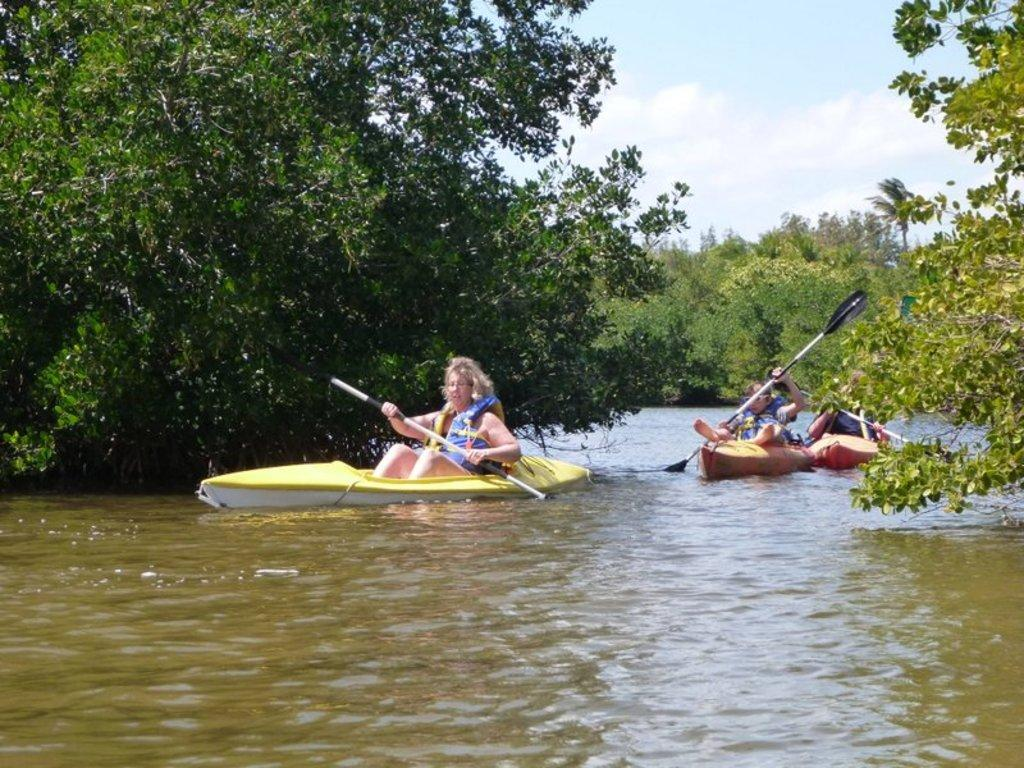How many people are in the image? There are three people in the image. What are the people doing in the image? The people are sitting in boats and holding rows. Where are the boats located? The boats are in a large water body. What can be seen in the background of the image? There is a group of trees visible in the image, and the sky is cloudy. Are the people wearing veils in the image? There is no mention of veils in the image, and no veils are visible in the image. Are the people in the image sisters? There is no information provided about the relationship between the people in the image, so we cannot determine if they are sisters. 